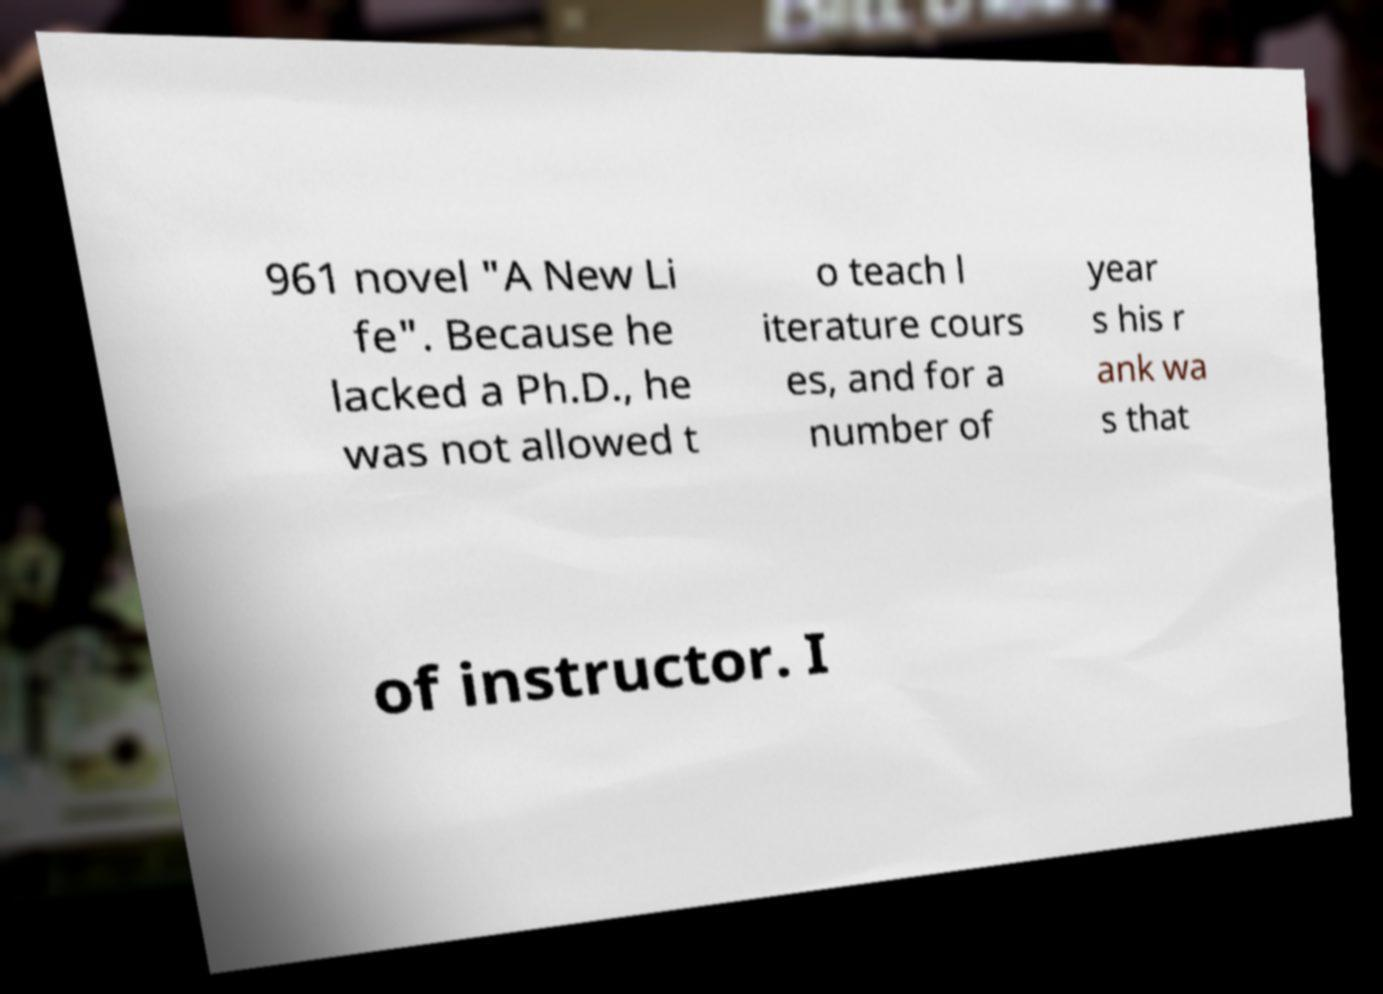Can you accurately transcribe the text from the provided image for me? 961 novel "A New Li fe". Because he lacked a Ph.D., he was not allowed t o teach l iterature cours es, and for a number of year s his r ank wa s that of instructor. I 